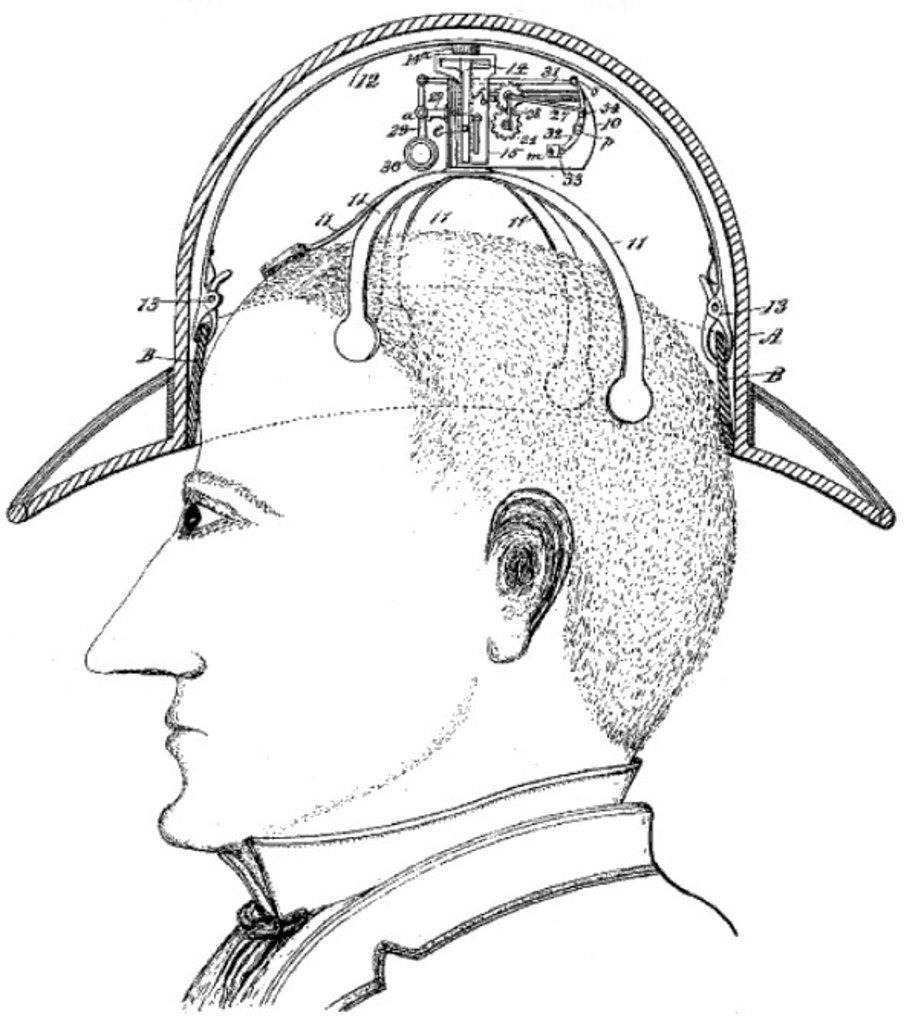In one or two sentences, can you explain what this image depicts? In this image we can see the drawing of a person with some numbers and a device on it. 